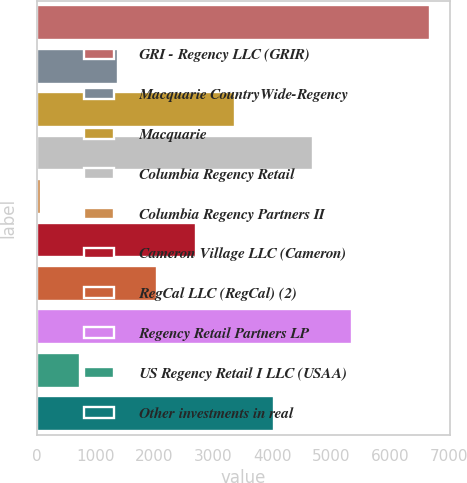Convert chart to OTSL. <chart><loc_0><loc_0><loc_500><loc_500><bar_chart><fcel>GRI - Regency LLC (GRIR)<fcel>Macquarie CountryWide-Regency<fcel>Macquarie<fcel>Columbia Regency Retail<fcel>Columbia Regency Partners II<fcel>Cameron Village LLC (Cameron)<fcel>RegCal LLC (RegCal) (2)<fcel>Regency Retail Partners LP<fcel>US Regency Retail I LLC (USAA)<fcel>Other investments in real<nl><fcel>6672<fcel>1389.6<fcel>3370.5<fcel>4691.1<fcel>69<fcel>2710.2<fcel>2049.9<fcel>5351.4<fcel>729.3<fcel>4030.8<nl></chart> 